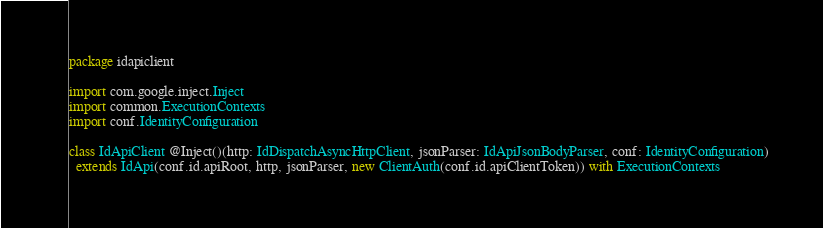<code> <loc_0><loc_0><loc_500><loc_500><_Scala_>package idapiclient

import com.google.inject.Inject
import common.ExecutionContexts
import conf.IdentityConfiguration

class IdApiClient @Inject()(http: IdDispatchAsyncHttpClient, jsonParser: IdApiJsonBodyParser, conf: IdentityConfiguration)
  extends IdApi(conf.id.apiRoot, http, jsonParser, new ClientAuth(conf.id.apiClientToken)) with ExecutionContexts
</code> 